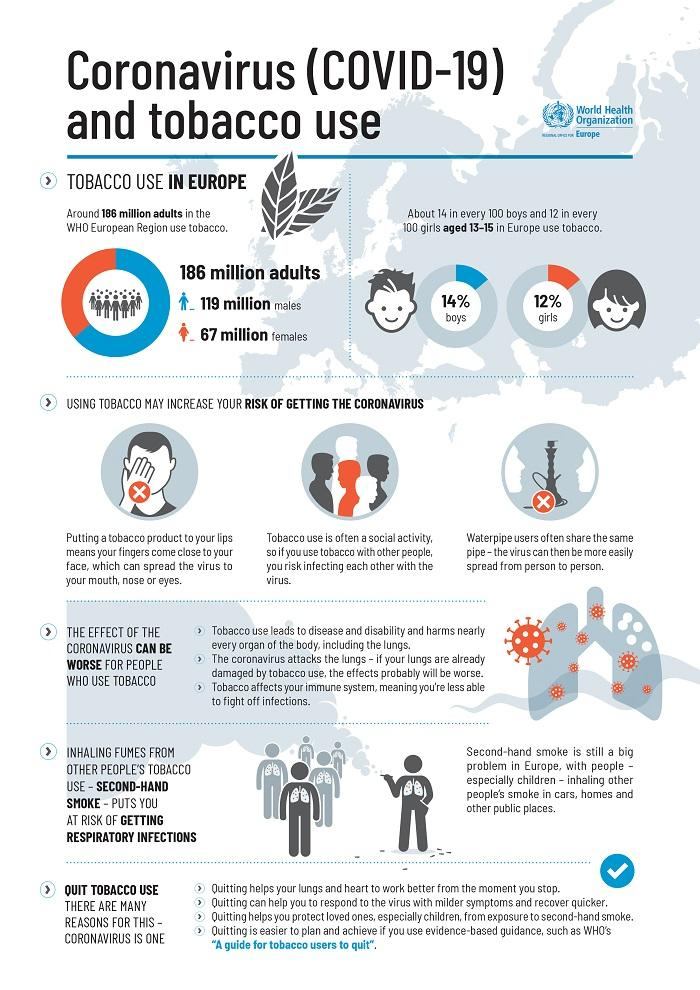Specify some key components in this picture. The World Health Organization reports that 67 million women in Europe engage in tobacco consumption. According to the World Health Organization, 14% of boys aged 13-15 in Europe use tobacco. According to the World Health Organization, approximately 119 million males in Europe are tobacco users. According to the World Health Organization, 12% of girls aged 13-15 in Europe use tobacco. 